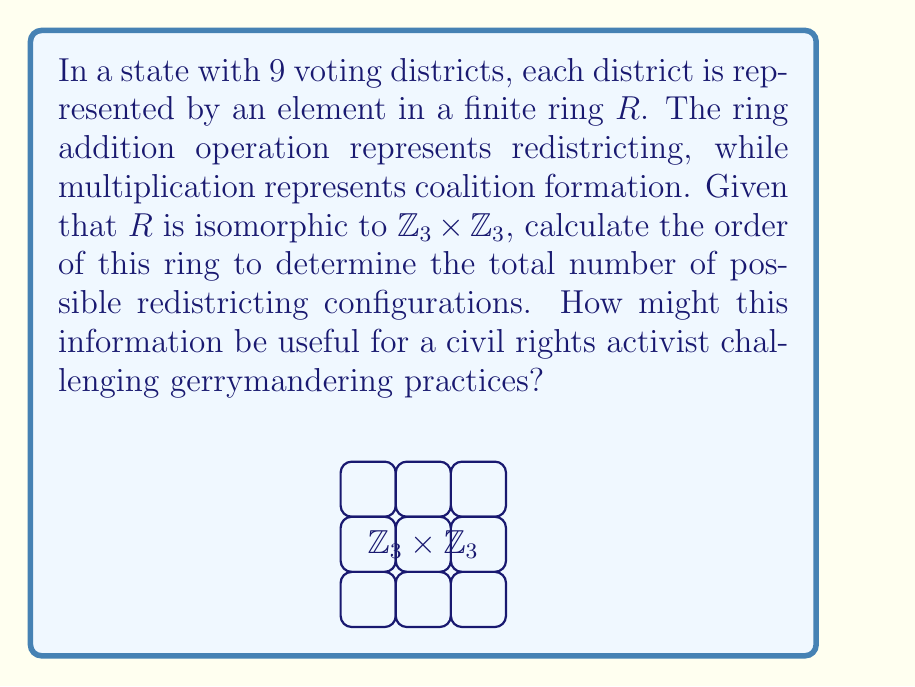What is the answer to this math problem? To calculate the order of the finite ring $R$ representing voting districts:

1) Given: $R \cong \mathbb{Z}_3 \times \mathbb{Z}_3$

2) The order of a ring is the number of elements in the ring.

3) For $\mathbb{Z}_3 \times \mathbb{Z}_3$:
   - $\mathbb{Z}_3$ has 3 elements: $\{0, 1, 2\}$
   - The Cartesian product creates ordered pairs: $(a,b)$ where $a,b \in \mathbb{Z}_3$

4) Total number of possible ordered pairs:
   $|\mathbb{Z}_3 \times \mathbb{Z}_3| = |\mathbb{Z}_3| \cdot |\mathbb{Z}_3| = 3 \cdot 3 = 9$

5) Therefore, the order of $R$ is 9.

For a civil rights activist, this information reveals:
- The total number of possible redistricting configurations (9)
- The mathematical structure underlying the districting system
- A framework for analyzing potential gerrymandering practices by examining how redistricting operations (ring addition) and coalition formations (ring multiplication) affect voting outcomes
Answer: $|R| = 9$ 